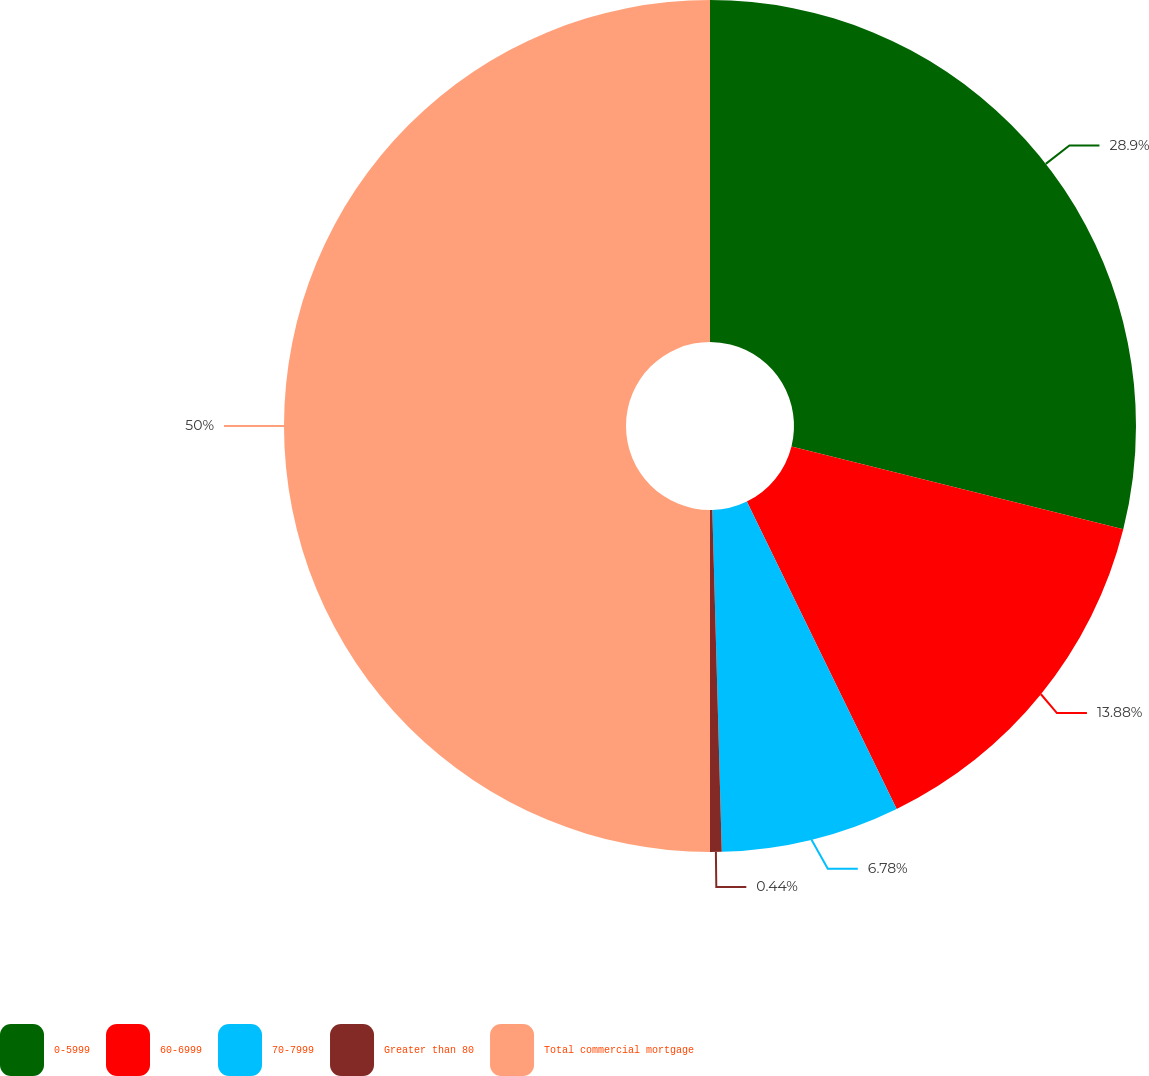Convert chart to OTSL. <chart><loc_0><loc_0><loc_500><loc_500><pie_chart><fcel>0-5999<fcel>60-6999<fcel>70-7999<fcel>Greater than 80<fcel>Total commercial mortgage<nl><fcel>28.9%<fcel>13.88%<fcel>6.78%<fcel>0.44%<fcel>50.0%<nl></chart> 